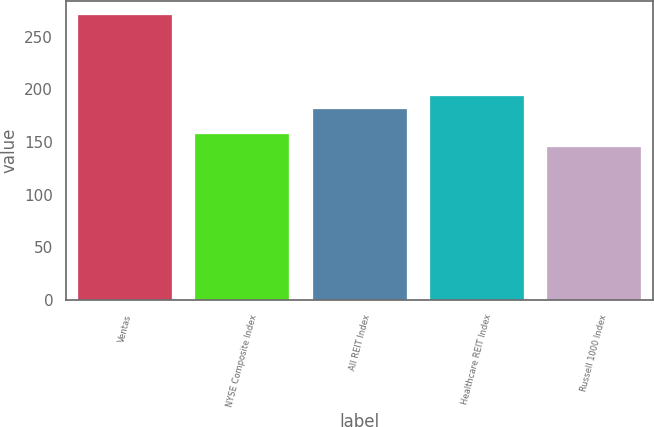<chart> <loc_0><loc_0><loc_500><loc_500><bar_chart><fcel>Ventas<fcel>NYSE Composite Index<fcel>All REIT Index<fcel>Healthcare REIT Index<fcel>Russell 1000 Index<nl><fcel>270<fcel>157.5<fcel>181<fcel>193.5<fcel>145<nl></chart> 